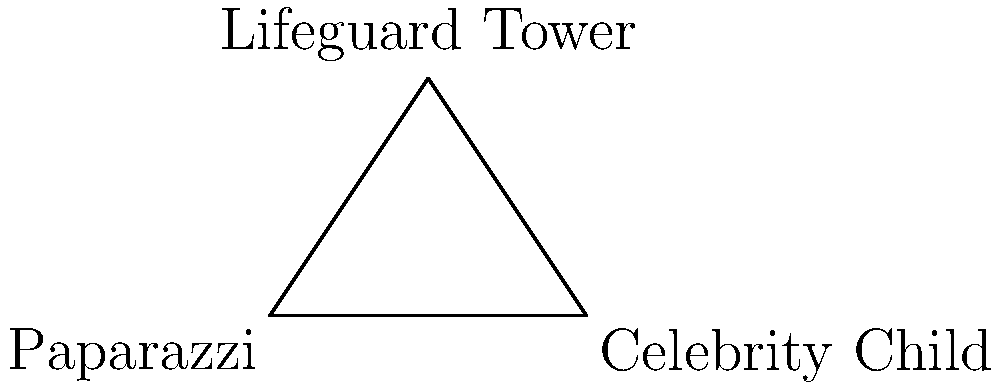At a popular beach, a paparazzi is trying to photograph a celebrity's child from a distance. The paparazzi, the celebrity child, and a lifeguard tower form a triangle. The distance between the paparazzi and the celebrity child is 300 meters. The angle between the paparazzi's line of sight to the child and the tower is 30°, while the angle between the child's line of sight to the paparazzi and the tower is 45°. What is the distance between the paparazzi and the lifeguard tower? Let's solve this step-by-step using the law of sines:

1) Let's define our variables:
   A: Paparazzi
   B: Celebrity Child
   C: Lifeguard Tower
   a: distance BC (Child to Tower)
   b: distance AC (Paparazzi to Tower)
   c: distance AB (Paparazzi to Child) = 300 m

2) We know that angle A is 30° and angle B is 45°. The sum of angles in a triangle is 180°, so angle C must be:
   C = 180° - 30° - 45° = 105°

3) The law of sines states: 
   $$\frac{a}{\sin A} = \frac{b}{\sin B} = \frac{c}{\sin C}$$

4) We want to find b (distance from Paparazzi to Tower). We can use:
   $$\frac{b}{\sin B} = \frac{c}{\sin C}$$

5) Rearranging to solve for b:
   $$b = \frac{c \sin B}{\sin C}$$

6) Now let's plug in our known values:
   $$b = \frac{300 \sin 45°}{\sin 105°}$$

7) Using a calculator (or knowing exact values):
   $$b = \frac{300 \times 0.7071}{0.9659} \approx 219.8$$

Therefore, the distance between the paparazzi and the lifeguard tower is approximately 219.8 meters.
Answer: 219.8 meters 